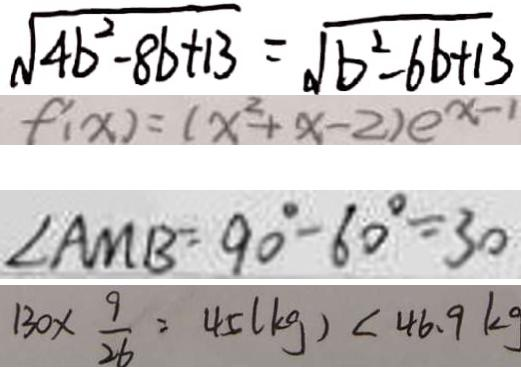Convert formula to latex. <formula><loc_0><loc_0><loc_500><loc_500>\sqrt { 4 b ^ { 2 } - 8 b + 1 3 } = \sqrt { b ^ { 2 } - 6 b + 1 3 } 
 f ^ { \prime } ( x ) = ( x ^ { 2 } + x - 2 ) e ^ { x - 1 } 
 \angle A M B = 9 0 ^ { \circ } - 6 0 ^ { \circ } = 3 0 
 1 3 0 \times \frac { 9 } { 2 6 } = 4 5 ( k g ) < 4 6 . 9 k g</formula> 